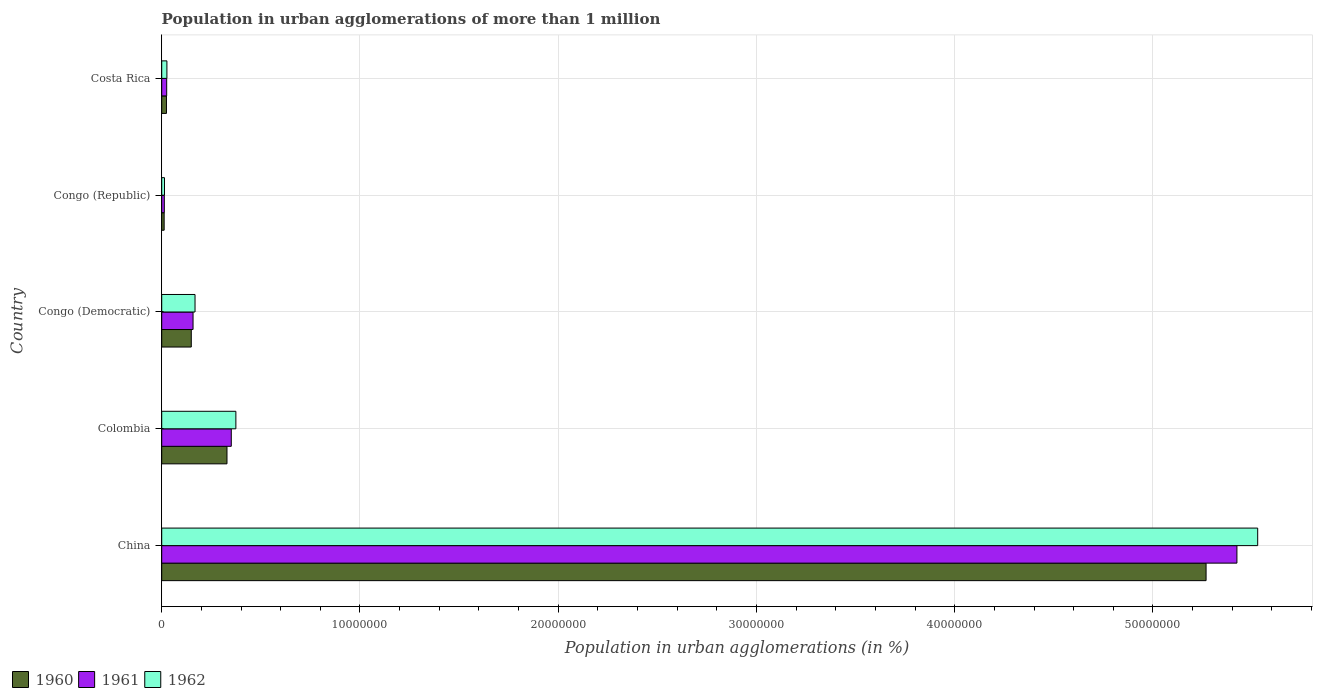Are the number of bars per tick equal to the number of legend labels?
Provide a succinct answer. Yes. How many bars are there on the 3rd tick from the top?
Your answer should be very brief. 3. What is the label of the 4th group of bars from the top?
Make the answer very short. Colombia. In how many cases, is the number of bars for a given country not equal to the number of legend labels?
Your answer should be very brief. 0. What is the population in urban agglomerations in 1960 in Congo (Republic)?
Provide a succinct answer. 1.24e+05. Across all countries, what is the maximum population in urban agglomerations in 1960?
Your answer should be very brief. 5.27e+07. Across all countries, what is the minimum population in urban agglomerations in 1960?
Your answer should be very brief. 1.24e+05. In which country was the population in urban agglomerations in 1962 minimum?
Offer a terse response. Congo (Republic). What is the total population in urban agglomerations in 1962 in the graph?
Give a very brief answer. 6.11e+07. What is the difference between the population in urban agglomerations in 1960 in Colombia and that in Congo (Democratic)?
Give a very brief answer. 1.80e+06. What is the difference between the population in urban agglomerations in 1962 in Congo (Democratic) and the population in urban agglomerations in 1961 in Costa Rica?
Provide a succinct answer. 1.43e+06. What is the average population in urban agglomerations in 1962 per country?
Offer a terse response. 1.22e+07. What is the difference between the population in urban agglomerations in 1962 and population in urban agglomerations in 1961 in China?
Your answer should be compact. 1.05e+06. What is the ratio of the population in urban agglomerations in 1960 in China to that in Colombia?
Your answer should be very brief. 16. Is the difference between the population in urban agglomerations in 1962 in China and Colombia greater than the difference between the population in urban agglomerations in 1961 in China and Colombia?
Your answer should be very brief. Yes. What is the difference between the highest and the second highest population in urban agglomerations in 1962?
Offer a terse response. 5.15e+07. What is the difference between the highest and the lowest population in urban agglomerations in 1961?
Offer a very short reply. 5.41e+07. Is the sum of the population in urban agglomerations in 1961 in Congo (Republic) and Costa Rica greater than the maximum population in urban agglomerations in 1960 across all countries?
Give a very brief answer. No. What does the 2nd bar from the bottom in Congo (Republic) represents?
Give a very brief answer. 1961. Is it the case that in every country, the sum of the population in urban agglomerations in 1962 and population in urban agglomerations in 1960 is greater than the population in urban agglomerations in 1961?
Your response must be concise. Yes. Does the graph contain grids?
Provide a short and direct response. Yes. Where does the legend appear in the graph?
Your answer should be compact. Bottom left. How are the legend labels stacked?
Ensure brevity in your answer.  Horizontal. What is the title of the graph?
Keep it short and to the point. Population in urban agglomerations of more than 1 million. What is the label or title of the X-axis?
Ensure brevity in your answer.  Population in urban agglomerations (in %). What is the Population in urban agglomerations (in %) of 1960 in China?
Your response must be concise. 5.27e+07. What is the Population in urban agglomerations (in %) in 1961 in China?
Provide a succinct answer. 5.42e+07. What is the Population in urban agglomerations (in %) of 1962 in China?
Offer a terse response. 5.53e+07. What is the Population in urban agglomerations (in %) of 1960 in Colombia?
Keep it short and to the point. 3.29e+06. What is the Population in urban agglomerations (in %) of 1961 in Colombia?
Ensure brevity in your answer.  3.51e+06. What is the Population in urban agglomerations (in %) of 1962 in Colombia?
Your response must be concise. 3.74e+06. What is the Population in urban agglomerations (in %) in 1960 in Congo (Democratic)?
Your response must be concise. 1.49e+06. What is the Population in urban agglomerations (in %) in 1961 in Congo (Democratic)?
Make the answer very short. 1.58e+06. What is the Population in urban agglomerations (in %) in 1962 in Congo (Democratic)?
Your answer should be compact. 1.68e+06. What is the Population in urban agglomerations (in %) in 1960 in Congo (Republic)?
Your answer should be very brief. 1.24e+05. What is the Population in urban agglomerations (in %) of 1961 in Congo (Republic)?
Offer a terse response. 1.32e+05. What is the Population in urban agglomerations (in %) of 1962 in Congo (Republic)?
Your response must be concise. 1.41e+05. What is the Population in urban agglomerations (in %) of 1960 in Costa Rica?
Your response must be concise. 2.40e+05. What is the Population in urban agglomerations (in %) in 1961 in Costa Rica?
Make the answer very short. 2.51e+05. What is the Population in urban agglomerations (in %) in 1962 in Costa Rica?
Ensure brevity in your answer.  2.62e+05. Across all countries, what is the maximum Population in urban agglomerations (in %) in 1960?
Provide a succinct answer. 5.27e+07. Across all countries, what is the maximum Population in urban agglomerations (in %) of 1961?
Your answer should be compact. 5.42e+07. Across all countries, what is the maximum Population in urban agglomerations (in %) in 1962?
Your answer should be compact. 5.53e+07. Across all countries, what is the minimum Population in urban agglomerations (in %) of 1960?
Make the answer very short. 1.24e+05. Across all countries, what is the minimum Population in urban agglomerations (in %) in 1961?
Provide a short and direct response. 1.32e+05. Across all countries, what is the minimum Population in urban agglomerations (in %) in 1962?
Give a very brief answer. 1.41e+05. What is the total Population in urban agglomerations (in %) of 1960 in the graph?
Ensure brevity in your answer.  5.78e+07. What is the total Population in urban agglomerations (in %) in 1961 in the graph?
Ensure brevity in your answer.  5.97e+07. What is the total Population in urban agglomerations (in %) of 1962 in the graph?
Ensure brevity in your answer.  6.11e+07. What is the difference between the Population in urban agglomerations (in %) in 1960 in China and that in Colombia?
Give a very brief answer. 4.94e+07. What is the difference between the Population in urban agglomerations (in %) in 1961 in China and that in Colombia?
Give a very brief answer. 5.07e+07. What is the difference between the Population in urban agglomerations (in %) of 1962 in China and that in Colombia?
Ensure brevity in your answer.  5.15e+07. What is the difference between the Population in urban agglomerations (in %) in 1960 in China and that in Congo (Democratic)?
Provide a succinct answer. 5.12e+07. What is the difference between the Population in urban agglomerations (in %) in 1961 in China and that in Congo (Democratic)?
Your answer should be very brief. 5.27e+07. What is the difference between the Population in urban agglomerations (in %) in 1962 in China and that in Congo (Democratic)?
Make the answer very short. 5.36e+07. What is the difference between the Population in urban agglomerations (in %) in 1960 in China and that in Congo (Republic)?
Offer a terse response. 5.26e+07. What is the difference between the Population in urban agglomerations (in %) of 1961 in China and that in Congo (Republic)?
Offer a terse response. 5.41e+07. What is the difference between the Population in urban agglomerations (in %) in 1962 in China and that in Congo (Republic)?
Provide a succinct answer. 5.51e+07. What is the difference between the Population in urban agglomerations (in %) in 1960 in China and that in Costa Rica?
Your response must be concise. 5.24e+07. What is the difference between the Population in urban agglomerations (in %) in 1961 in China and that in Costa Rica?
Make the answer very short. 5.40e+07. What is the difference between the Population in urban agglomerations (in %) in 1962 in China and that in Costa Rica?
Provide a succinct answer. 5.50e+07. What is the difference between the Population in urban agglomerations (in %) in 1960 in Colombia and that in Congo (Democratic)?
Your answer should be compact. 1.80e+06. What is the difference between the Population in urban agglomerations (in %) in 1961 in Colombia and that in Congo (Democratic)?
Provide a short and direct response. 1.93e+06. What is the difference between the Population in urban agglomerations (in %) of 1962 in Colombia and that in Congo (Democratic)?
Provide a short and direct response. 2.06e+06. What is the difference between the Population in urban agglomerations (in %) in 1960 in Colombia and that in Congo (Republic)?
Provide a succinct answer. 3.17e+06. What is the difference between the Population in urban agglomerations (in %) in 1961 in Colombia and that in Congo (Republic)?
Keep it short and to the point. 3.38e+06. What is the difference between the Population in urban agglomerations (in %) of 1962 in Colombia and that in Congo (Republic)?
Provide a short and direct response. 3.60e+06. What is the difference between the Population in urban agglomerations (in %) in 1960 in Colombia and that in Costa Rica?
Ensure brevity in your answer.  3.05e+06. What is the difference between the Population in urban agglomerations (in %) in 1961 in Colombia and that in Costa Rica?
Keep it short and to the point. 3.26e+06. What is the difference between the Population in urban agglomerations (in %) of 1962 in Colombia and that in Costa Rica?
Offer a terse response. 3.48e+06. What is the difference between the Population in urban agglomerations (in %) of 1960 in Congo (Democratic) and that in Congo (Republic)?
Offer a very short reply. 1.37e+06. What is the difference between the Population in urban agglomerations (in %) of 1961 in Congo (Democratic) and that in Congo (Republic)?
Make the answer very short. 1.45e+06. What is the difference between the Population in urban agglomerations (in %) of 1962 in Congo (Democratic) and that in Congo (Republic)?
Your response must be concise. 1.54e+06. What is the difference between the Population in urban agglomerations (in %) in 1960 in Congo (Democratic) and that in Costa Rica?
Offer a very short reply. 1.25e+06. What is the difference between the Population in urban agglomerations (in %) of 1961 in Congo (Democratic) and that in Costa Rica?
Provide a short and direct response. 1.33e+06. What is the difference between the Population in urban agglomerations (in %) of 1962 in Congo (Democratic) and that in Costa Rica?
Make the answer very short. 1.42e+06. What is the difference between the Population in urban agglomerations (in %) of 1960 in Congo (Republic) and that in Costa Rica?
Your response must be concise. -1.17e+05. What is the difference between the Population in urban agglomerations (in %) in 1961 in Congo (Republic) and that in Costa Rica?
Keep it short and to the point. -1.19e+05. What is the difference between the Population in urban agglomerations (in %) of 1962 in Congo (Republic) and that in Costa Rica?
Your answer should be very brief. -1.22e+05. What is the difference between the Population in urban agglomerations (in %) of 1960 in China and the Population in urban agglomerations (in %) of 1961 in Colombia?
Your answer should be compact. 4.92e+07. What is the difference between the Population in urban agglomerations (in %) of 1960 in China and the Population in urban agglomerations (in %) of 1962 in Colombia?
Make the answer very short. 4.89e+07. What is the difference between the Population in urban agglomerations (in %) of 1961 in China and the Population in urban agglomerations (in %) of 1962 in Colombia?
Your response must be concise. 5.05e+07. What is the difference between the Population in urban agglomerations (in %) of 1960 in China and the Population in urban agglomerations (in %) of 1961 in Congo (Democratic)?
Provide a succinct answer. 5.11e+07. What is the difference between the Population in urban agglomerations (in %) of 1960 in China and the Population in urban agglomerations (in %) of 1962 in Congo (Democratic)?
Offer a very short reply. 5.10e+07. What is the difference between the Population in urban agglomerations (in %) of 1961 in China and the Population in urban agglomerations (in %) of 1962 in Congo (Democratic)?
Offer a terse response. 5.26e+07. What is the difference between the Population in urban agglomerations (in %) in 1960 in China and the Population in urban agglomerations (in %) in 1961 in Congo (Republic)?
Your answer should be very brief. 5.25e+07. What is the difference between the Population in urban agglomerations (in %) of 1960 in China and the Population in urban agglomerations (in %) of 1962 in Congo (Republic)?
Provide a short and direct response. 5.25e+07. What is the difference between the Population in urban agglomerations (in %) in 1961 in China and the Population in urban agglomerations (in %) in 1962 in Congo (Republic)?
Provide a succinct answer. 5.41e+07. What is the difference between the Population in urban agglomerations (in %) of 1960 in China and the Population in urban agglomerations (in %) of 1961 in Costa Rica?
Provide a succinct answer. 5.24e+07. What is the difference between the Population in urban agglomerations (in %) of 1960 in China and the Population in urban agglomerations (in %) of 1962 in Costa Rica?
Make the answer very short. 5.24e+07. What is the difference between the Population in urban agglomerations (in %) in 1961 in China and the Population in urban agglomerations (in %) in 1962 in Costa Rica?
Your answer should be compact. 5.40e+07. What is the difference between the Population in urban agglomerations (in %) in 1960 in Colombia and the Population in urban agglomerations (in %) in 1961 in Congo (Democratic)?
Make the answer very short. 1.71e+06. What is the difference between the Population in urban agglomerations (in %) of 1960 in Colombia and the Population in urban agglomerations (in %) of 1962 in Congo (Democratic)?
Ensure brevity in your answer.  1.61e+06. What is the difference between the Population in urban agglomerations (in %) in 1961 in Colombia and the Population in urban agglomerations (in %) in 1962 in Congo (Democratic)?
Provide a short and direct response. 1.83e+06. What is the difference between the Population in urban agglomerations (in %) of 1960 in Colombia and the Population in urban agglomerations (in %) of 1961 in Congo (Republic)?
Your response must be concise. 3.16e+06. What is the difference between the Population in urban agglomerations (in %) in 1960 in Colombia and the Population in urban agglomerations (in %) in 1962 in Congo (Republic)?
Ensure brevity in your answer.  3.15e+06. What is the difference between the Population in urban agglomerations (in %) of 1961 in Colombia and the Population in urban agglomerations (in %) of 1962 in Congo (Republic)?
Give a very brief answer. 3.37e+06. What is the difference between the Population in urban agglomerations (in %) of 1960 in Colombia and the Population in urban agglomerations (in %) of 1961 in Costa Rica?
Make the answer very short. 3.04e+06. What is the difference between the Population in urban agglomerations (in %) of 1960 in Colombia and the Population in urban agglomerations (in %) of 1962 in Costa Rica?
Provide a short and direct response. 3.03e+06. What is the difference between the Population in urban agglomerations (in %) of 1961 in Colombia and the Population in urban agglomerations (in %) of 1962 in Costa Rica?
Your answer should be compact. 3.25e+06. What is the difference between the Population in urban agglomerations (in %) of 1960 in Congo (Democratic) and the Population in urban agglomerations (in %) of 1961 in Congo (Republic)?
Provide a short and direct response. 1.36e+06. What is the difference between the Population in urban agglomerations (in %) of 1960 in Congo (Democratic) and the Population in urban agglomerations (in %) of 1962 in Congo (Republic)?
Offer a terse response. 1.35e+06. What is the difference between the Population in urban agglomerations (in %) of 1961 in Congo (Democratic) and the Population in urban agglomerations (in %) of 1962 in Congo (Republic)?
Your answer should be very brief. 1.44e+06. What is the difference between the Population in urban agglomerations (in %) of 1960 in Congo (Democratic) and the Population in urban agglomerations (in %) of 1961 in Costa Rica?
Give a very brief answer. 1.24e+06. What is the difference between the Population in urban agglomerations (in %) in 1960 in Congo (Democratic) and the Population in urban agglomerations (in %) in 1962 in Costa Rica?
Your answer should be compact. 1.23e+06. What is the difference between the Population in urban agglomerations (in %) in 1961 in Congo (Democratic) and the Population in urban agglomerations (in %) in 1962 in Costa Rica?
Give a very brief answer. 1.32e+06. What is the difference between the Population in urban agglomerations (in %) of 1960 in Congo (Republic) and the Population in urban agglomerations (in %) of 1961 in Costa Rica?
Your answer should be compact. -1.27e+05. What is the difference between the Population in urban agglomerations (in %) in 1960 in Congo (Republic) and the Population in urban agglomerations (in %) in 1962 in Costa Rica?
Offer a terse response. -1.39e+05. What is the difference between the Population in urban agglomerations (in %) of 1961 in Congo (Republic) and the Population in urban agglomerations (in %) of 1962 in Costa Rica?
Your answer should be very brief. -1.30e+05. What is the average Population in urban agglomerations (in %) of 1960 per country?
Provide a succinct answer. 1.16e+07. What is the average Population in urban agglomerations (in %) in 1961 per country?
Provide a short and direct response. 1.19e+07. What is the average Population in urban agglomerations (in %) in 1962 per country?
Make the answer very short. 1.22e+07. What is the difference between the Population in urban agglomerations (in %) in 1960 and Population in urban agglomerations (in %) in 1961 in China?
Provide a succinct answer. -1.56e+06. What is the difference between the Population in urban agglomerations (in %) in 1960 and Population in urban agglomerations (in %) in 1962 in China?
Your answer should be compact. -2.60e+06. What is the difference between the Population in urban agglomerations (in %) of 1961 and Population in urban agglomerations (in %) of 1962 in China?
Keep it short and to the point. -1.05e+06. What is the difference between the Population in urban agglomerations (in %) in 1960 and Population in urban agglomerations (in %) in 1961 in Colombia?
Your response must be concise. -2.17e+05. What is the difference between the Population in urban agglomerations (in %) in 1960 and Population in urban agglomerations (in %) in 1962 in Colombia?
Offer a very short reply. -4.48e+05. What is the difference between the Population in urban agglomerations (in %) in 1961 and Population in urban agglomerations (in %) in 1962 in Colombia?
Keep it short and to the point. -2.32e+05. What is the difference between the Population in urban agglomerations (in %) in 1960 and Population in urban agglomerations (in %) in 1961 in Congo (Democratic)?
Provide a short and direct response. -8.86e+04. What is the difference between the Population in urban agglomerations (in %) in 1960 and Population in urban agglomerations (in %) in 1962 in Congo (Democratic)?
Offer a terse response. -1.89e+05. What is the difference between the Population in urban agglomerations (in %) of 1961 and Population in urban agglomerations (in %) of 1962 in Congo (Democratic)?
Provide a succinct answer. -1.00e+05. What is the difference between the Population in urban agglomerations (in %) of 1960 and Population in urban agglomerations (in %) of 1961 in Congo (Republic)?
Offer a very short reply. -8224. What is the difference between the Population in urban agglomerations (in %) of 1960 and Population in urban agglomerations (in %) of 1962 in Congo (Republic)?
Provide a short and direct response. -1.71e+04. What is the difference between the Population in urban agglomerations (in %) in 1961 and Population in urban agglomerations (in %) in 1962 in Congo (Republic)?
Offer a very short reply. -8884. What is the difference between the Population in urban agglomerations (in %) of 1960 and Population in urban agglomerations (in %) of 1961 in Costa Rica?
Ensure brevity in your answer.  -1.08e+04. What is the difference between the Population in urban agglomerations (in %) of 1960 and Population in urban agglomerations (in %) of 1962 in Costa Rica?
Offer a terse response. -2.22e+04. What is the difference between the Population in urban agglomerations (in %) in 1961 and Population in urban agglomerations (in %) in 1962 in Costa Rica?
Your response must be concise. -1.14e+04. What is the ratio of the Population in urban agglomerations (in %) of 1960 in China to that in Colombia?
Give a very brief answer. 16. What is the ratio of the Population in urban agglomerations (in %) of 1961 in China to that in Colombia?
Ensure brevity in your answer.  15.46. What is the ratio of the Population in urban agglomerations (in %) of 1962 in China to that in Colombia?
Your answer should be compact. 14.78. What is the ratio of the Population in urban agglomerations (in %) in 1960 in China to that in Congo (Democratic)?
Offer a very short reply. 35.31. What is the ratio of the Population in urban agglomerations (in %) in 1961 in China to that in Congo (Democratic)?
Give a very brief answer. 34.32. What is the ratio of the Population in urban agglomerations (in %) in 1962 in China to that in Congo (Democratic)?
Your answer should be compact. 32.9. What is the ratio of the Population in urban agglomerations (in %) in 1960 in China to that in Congo (Republic)?
Offer a very short reply. 426.06. What is the ratio of the Population in urban agglomerations (in %) in 1961 in China to that in Congo (Republic)?
Provide a short and direct response. 411.28. What is the ratio of the Population in urban agglomerations (in %) in 1962 in China to that in Congo (Republic)?
Give a very brief answer. 392.76. What is the ratio of the Population in urban agglomerations (in %) in 1960 in China to that in Costa Rica?
Provide a succinct answer. 219.35. What is the ratio of the Population in urban agglomerations (in %) in 1961 in China to that in Costa Rica?
Provide a succinct answer. 216.07. What is the ratio of the Population in urban agglomerations (in %) of 1962 in China to that in Costa Rica?
Provide a succinct answer. 210.71. What is the ratio of the Population in urban agglomerations (in %) of 1960 in Colombia to that in Congo (Democratic)?
Your answer should be compact. 2.21. What is the ratio of the Population in urban agglomerations (in %) in 1961 in Colombia to that in Congo (Democratic)?
Give a very brief answer. 2.22. What is the ratio of the Population in urban agglomerations (in %) of 1962 in Colombia to that in Congo (Democratic)?
Your answer should be compact. 2.23. What is the ratio of the Population in urban agglomerations (in %) of 1960 in Colombia to that in Congo (Republic)?
Offer a very short reply. 26.63. What is the ratio of the Population in urban agglomerations (in %) of 1961 in Colombia to that in Congo (Republic)?
Ensure brevity in your answer.  26.61. What is the ratio of the Population in urban agglomerations (in %) in 1962 in Colombia to that in Congo (Republic)?
Your answer should be compact. 26.57. What is the ratio of the Population in urban agglomerations (in %) in 1960 in Colombia to that in Costa Rica?
Provide a succinct answer. 13.71. What is the ratio of the Population in urban agglomerations (in %) of 1961 in Colombia to that in Costa Rica?
Provide a short and direct response. 13.98. What is the ratio of the Population in urban agglomerations (in %) of 1962 in Colombia to that in Costa Rica?
Give a very brief answer. 14.26. What is the ratio of the Population in urban agglomerations (in %) in 1960 in Congo (Democratic) to that in Congo (Republic)?
Keep it short and to the point. 12.07. What is the ratio of the Population in urban agglomerations (in %) in 1961 in Congo (Democratic) to that in Congo (Republic)?
Your response must be concise. 11.98. What is the ratio of the Population in urban agglomerations (in %) of 1962 in Congo (Democratic) to that in Congo (Republic)?
Offer a very short reply. 11.94. What is the ratio of the Population in urban agglomerations (in %) in 1960 in Congo (Democratic) to that in Costa Rica?
Provide a short and direct response. 6.21. What is the ratio of the Population in urban agglomerations (in %) in 1961 in Congo (Democratic) to that in Costa Rica?
Make the answer very short. 6.3. What is the ratio of the Population in urban agglomerations (in %) of 1962 in Congo (Democratic) to that in Costa Rica?
Your response must be concise. 6.41. What is the ratio of the Population in urban agglomerations (in %) in 1960 in Congo (Republic) to that in Costa Rica?
Your response must be concise. 0.51. What is the ratio of the Population in urban agglomerations (in %) of 1961 in Congo (Republic) to that in Costa Rica?
Offer a very short reply. 0.53. What is the ratio of the Population in urban agglomerations (in %) in 1962 in Congo (Republic) to that in Costa Rica?
Your answer should be compact. 0.54. What is the difference between the highest and the second highest Population in urban agglomerations (in %) in 1960?
Provide a succinct answer. 4.94e+07. What is the difference between the highest and the second highest Population in urban agglomerations (in %) of 1961?
Your answer should be compact. 5.07e+07. What is the difference between the highest and the second highest Population in urban agglomerations (in %) of 1962?
Offer a terse response. 5.15e+07. What is the difference between the highest and the lowest Population in urban agglomerations (in %) of 1960?
Make the answer very short. 5.26e+07. What is the difference between the highest and the lowest Population in urban agglomerations (in %) in 1961?
Your response must be concise. 5.41e+07. What is the difference between the highest and the lowest Population in urban agglomerations (in %) in 1962?
Make the answer very short. 5.51e+07. 